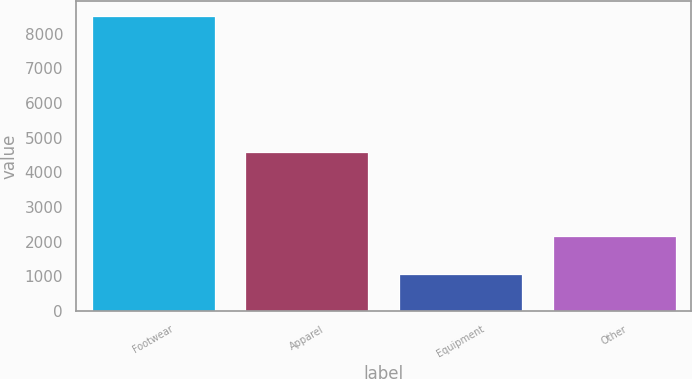<chart> <loc_0><loc_0><loc_500><loc_500><bar_chart><fcel>Footwear<fcel>Apparel<fcel>Equipment<fcel>Other<nl><fcel>8514<fcel>4576.5<fcel>1067.7<fcel>2167.7<nl></chart> 